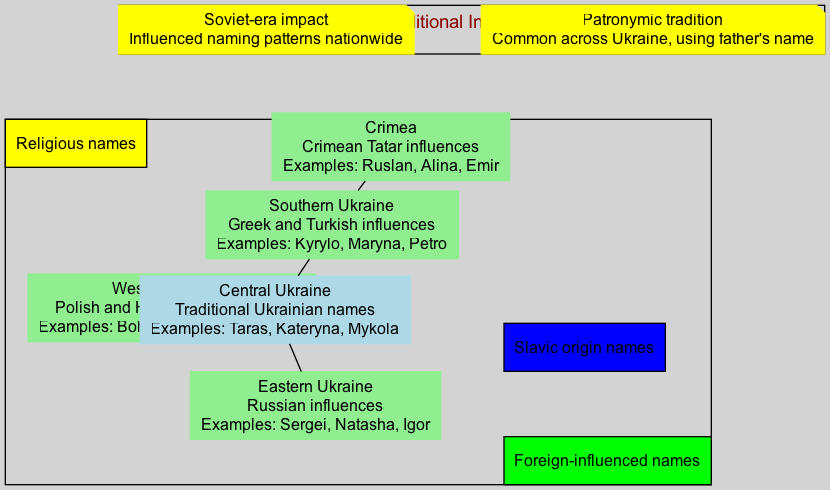What naming tradition is highlighted in Western Ukraine? The diagram specifies that Western Ukraine is influenced by Polish and Hungarian naming traditions. This is indicated in the main components section where the naming tradition for Western Ukraine is explicitly mentioned.
Answer: Polish and Hungarian influences What are the example names listed for Central Ukraine? According to the diagram, the example names for Central Ukraine include Taras, Kateryna, and Mykola. These names are highlighted specifically under the Central Ukraine section of the main components.
Answer: Taras, Kateryna, Mykola Which region has names influenced by Greek and Turkish traditions? In the diagram, Southern Ukraine is noted for having names that are influenced by Greek and Turkish traditions. This is directly stated in the main components of the diagram.
Answer: Southern Ukraine How many main regions are shown in the diagram? By counting the nodes representing the main regions listed in the diagram, there are five regions displayed: Western Ukraine, Central Ukraine, Eastern Ukraine, Southern Ukraine, and Crimea.
Answer: 5 What color represents foreign-influenced names in the legend? The legend indicates that the color green is used to represent foreign-influenced names. This is a specific detail found in the diagram's legend section.
Answer: Green Which naming tradition includes the use of a father's name? The diagram contains a piece of additional information stating that the patronymic tradition, which involves using the father's name, is common across Ukraine. This is detailed in the additional info section.
Answer: Patronymic tradition What are the example names for Crimea? The diagram lists the example names for Crimea as Ruslan, Alina, and Emir. This information is found directly in the Crimean section of the main components.
Answer: Ruslan, Alina, Emir What influence is seen in Eastern Ukraine naming traditions? The diagram shows that Eastern Ukraine's naming traditions are influenced by Russian traditions, as noted in the naming tradition description for this region.
Answer: Russian influences How did the Soviet era impact naming in Ukraine? The diagram provides a description in the additional information section stating that the Soviet era influenced naming patterns nationwide, capturing a significant historical context related to naming traditions.
Answer: Influenced naming patterns nationwide 